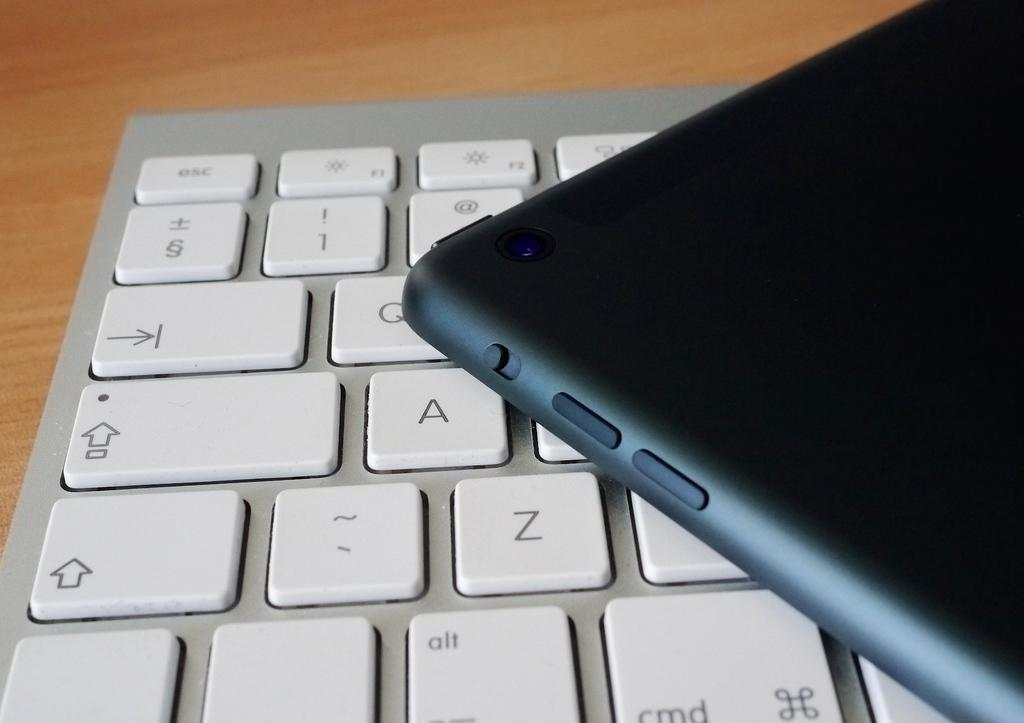<image>
Render a clear and concise summary of the photo. Black device on top of a white keyboard with the cmd on the bottom. 